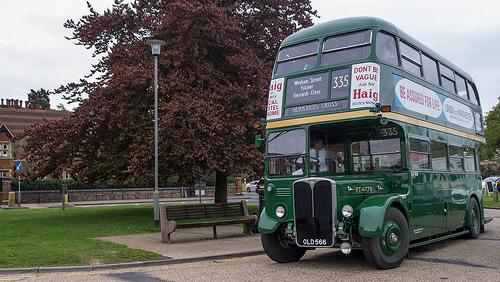Question: what is beside the bus?
Choices:
A. A car.
B. A sign.
C. Bench.
D. The sidewalk.
Answer with the letter. Answer: C Question: where is the light?
Choices:
A. Outside.
B. On the ceiling.
C. Behind the bench.
D. In the kitchen.
Answer with the letter. Answer: C Question: what type of vehicle is shown?
Choices:
A. Van.
B. Bus.
C. Truck.
D. Car.
Answer with the letter. Answer: B 